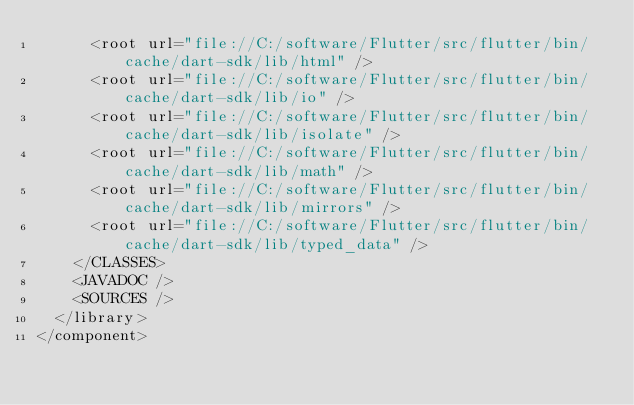Convert code to text. <code><loc_0><loc_0><loc_500><loc_500><_XML_>      <root url="file://C:/software/Flutter/src/flutter/bin/cache/dart-sdk/lib/html" />
      <root url="file://C:/software/Flutter/src/flutter/bin/cache/dart-sdk/lib/io" />
      <root url="file://C:/software/Flutter/src/flutter/bin/cache/dart-sdk/lib/isolate" />
      <root url="file://C:/software/Flutter/src/flutter/bin/cache/dart-sdk/lib/math" />
      <root url="file://C:/software/Flutter/src/flutter/bin/cache/dart-sdk/lib/mirrors" />
      <root url="file://C:/software/Flutter/src/flutter/bin/cache/dart-sdk/lib/typed_data" />
    </CLASSES>
    <JAVADOC />
    <SOURCES />
  </library>
</component></code> 